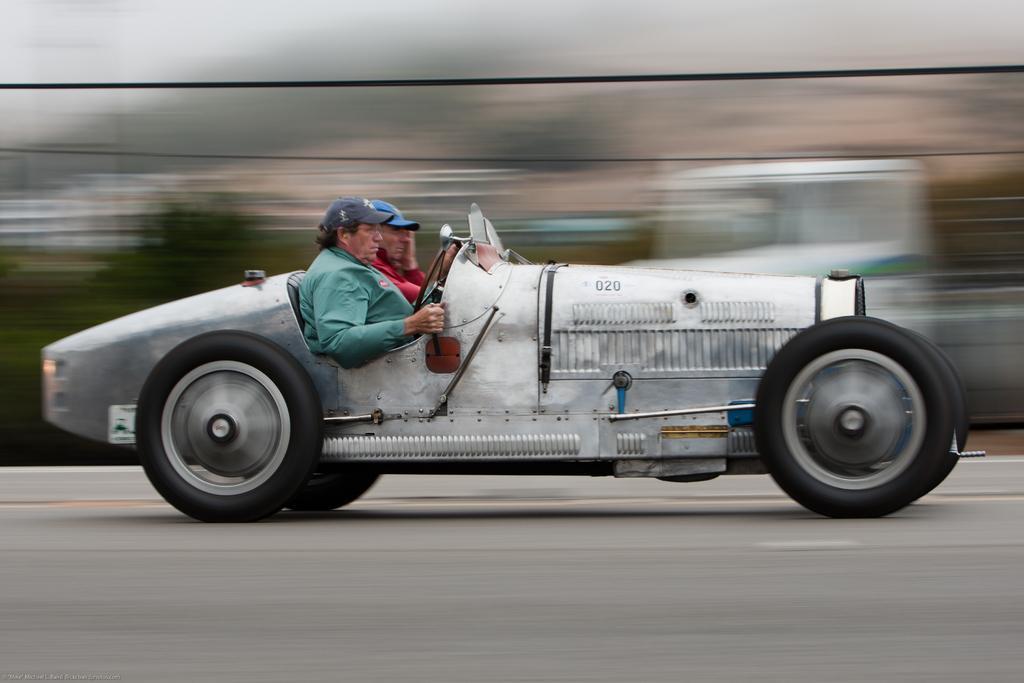In one or two sentences, can you explain what this image depicts? Here we can see two persons inside the vehicle. And this is road. 